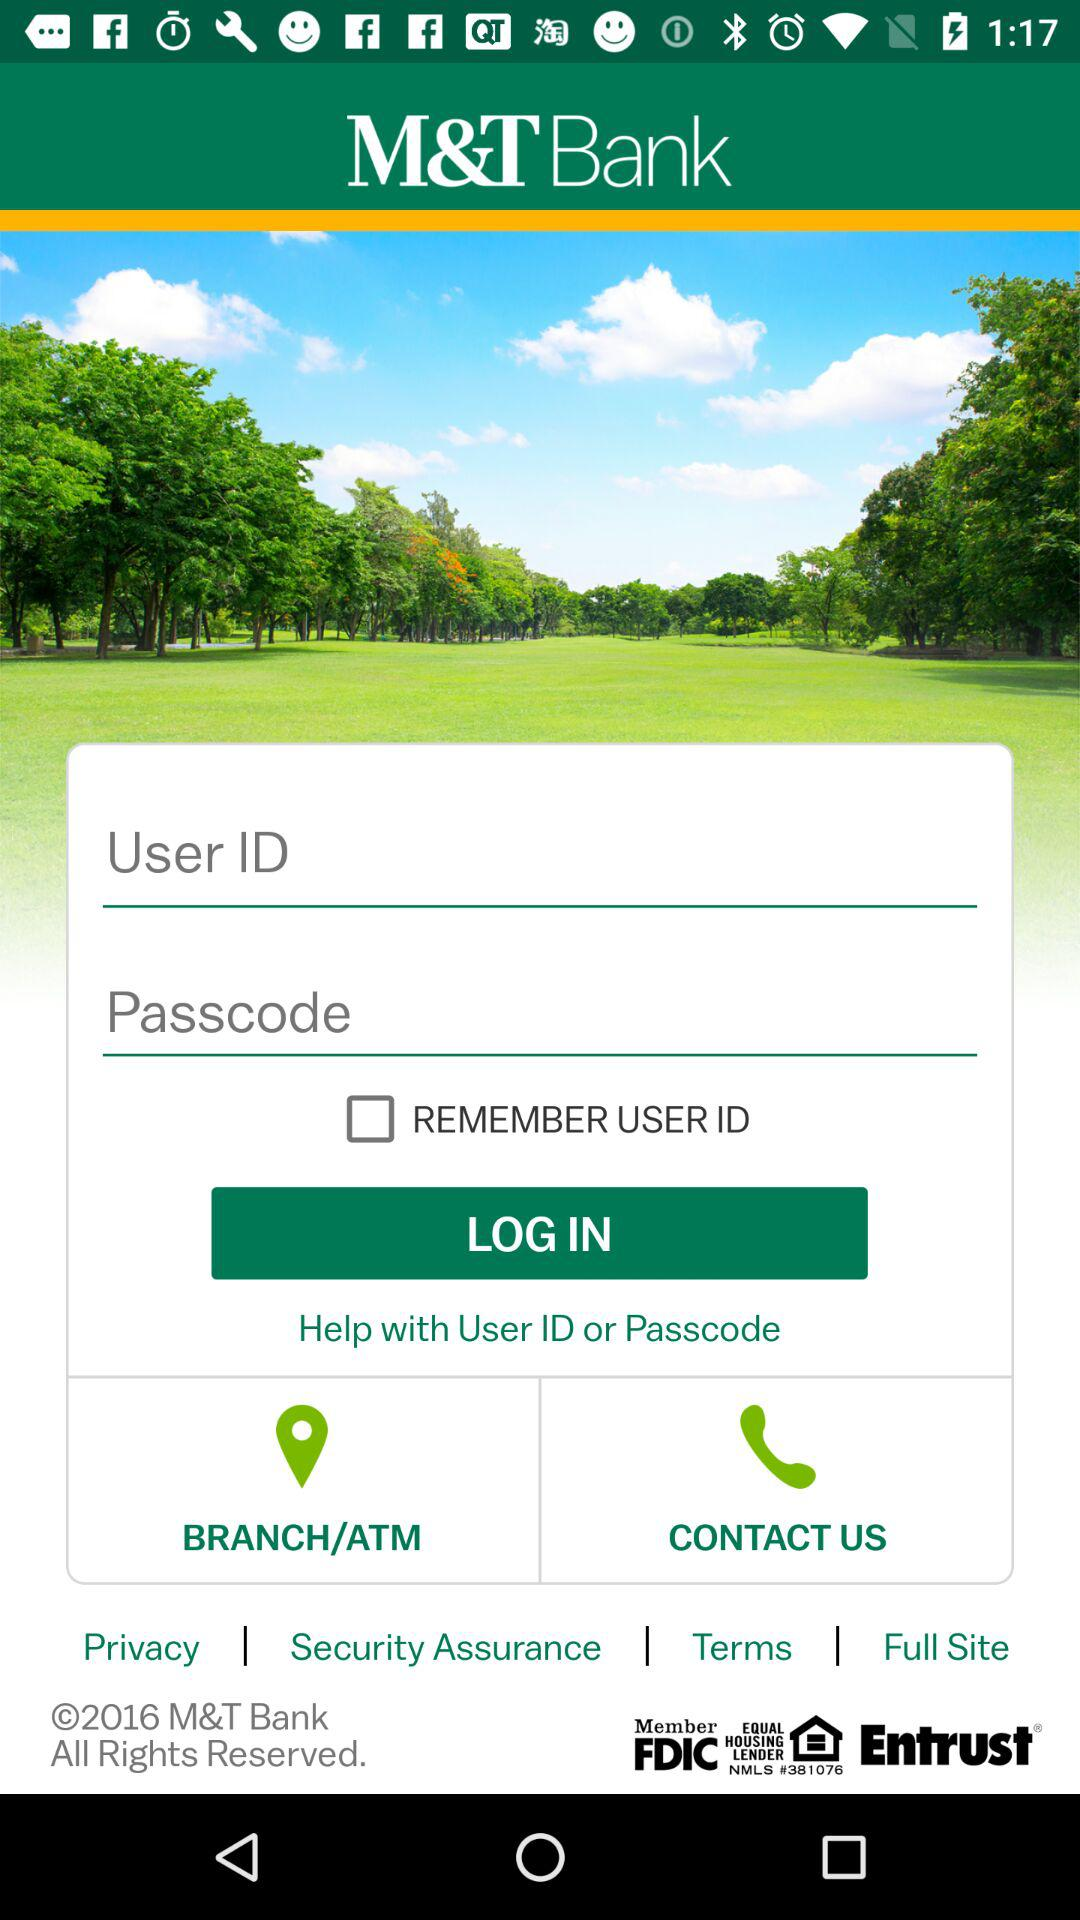How many more text inputs are there than checkboxes on this screen?
Answer the question using a single word or phrase. 1 